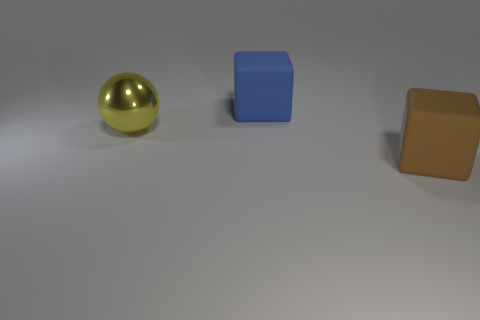Add 2 purple matte blocks. How many objects exist? 5 Subtract all spheres. How many objects are left? 2 Subtract 1 blue blocks. How many objects are left? 2 Subtract all blue things. Subtract all big blue cubes. How many objects are left? 1 Add 1 big matte objects. How many big matte objects are left? 3 Add 1 rubber objects. How many rubber objects exist? 3 